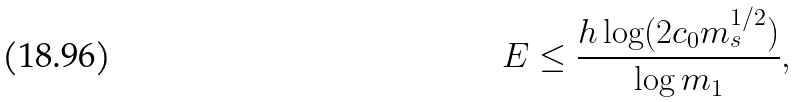Convert formula to latex. <formula><loc_0><loc_0><loc_500><loc_500>E \leq \frac { h \log ( 2 c _ { 0 } m _ { s } ^ { 1 / 2 } ) } { \log m _ { 1 } } ,</formula> 